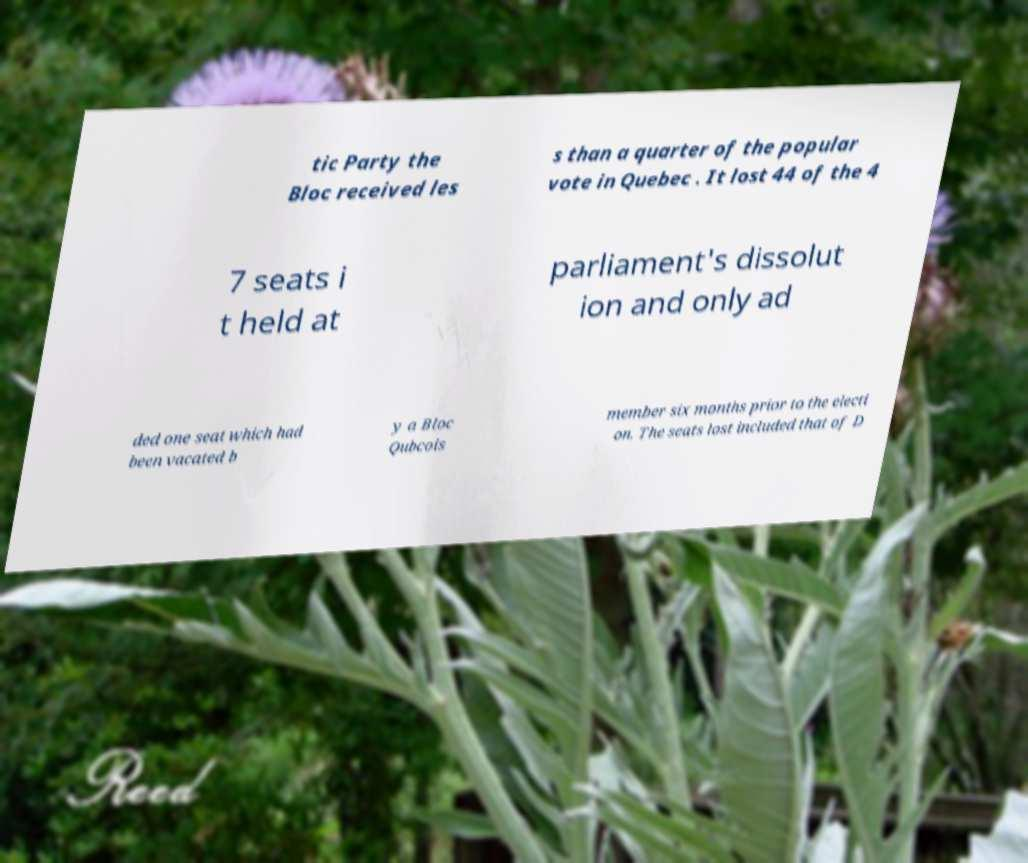There's text embedded in this image that I need extracted. Can you transcribe it verbatim? tic Party the Bloc received les s than a quarter of the popular vote in Quebec . It lost 44 of the 4 7 seats i t held at parliament's dissolut ion and only ad ded one seat which had been vacated b y a Bloc Qubcois member six months prior to the electi on. The seats lost included that of D 